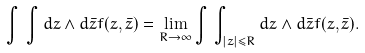<formula> <loc_0><loc_0><loc_500><loc_500>\int \, \int d z \wedge d \bar { z } f ( z , \bar { z } ) = \lim _ { R \to \infty } \int \, \int _ { | z | \leq R } d z \wedge d \bar { z } f ( z , \bar { z } ) .</formula> 